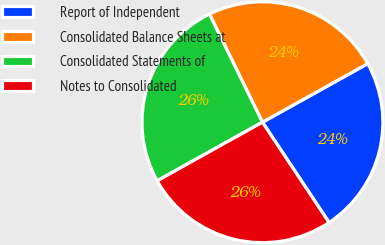<chart> <loc_0><loc_0><loc_500><loc_500><pie_chart><fcel>Report of Independent<fcel>Consolidated Balance Sheets at<fcel>Consolidated Statements of<fcel>Notes to Consolidated<nl><fcel>23.75%<fcel>24.17%<fcel>25.83%<fcel>26.25%<nl></chart> 